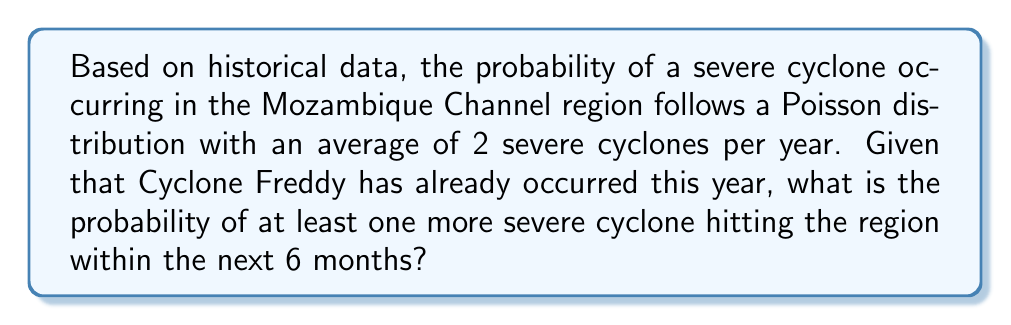Solve this math problem. Let's approach this step-by-step:

1) The Poisson distribution is given by the formula:

   $$P(X = k) = \frac{e^{-\lambda} \lambda^k}{k!}$$

   where $\lambda$ is the average number of events in the given time period, and $k$ is the number of events we're calculating the probability for.

2) We're given that the average is 2 cyclones per year. For 6 months, this becomes:

   $$\lambda = 2 * \frac{6}{12} = 1$$

3) We want to find the probability of at least one more cyclone, which is the same as the probability of not having zero cyclones. So:

   $$P(\text{at least one}) = 1 - P(\text{zero})$$

4) Calculate $P(\text{zero})$ using the Poisson formula:

   $$P(X = 0) = \frac{e^{-1} 1^0}{0!} = e^{-1} \approx 0.3679$$

5) Therefore, the probability of at least one cyclone is:

   $$P(\text{at least one}) = 1 - 0.3679 = 0.6321$$

6) Convert to a percentage:

   $$0.6321 * 100\% = 63.21\%$$
Answer: 63.21% 